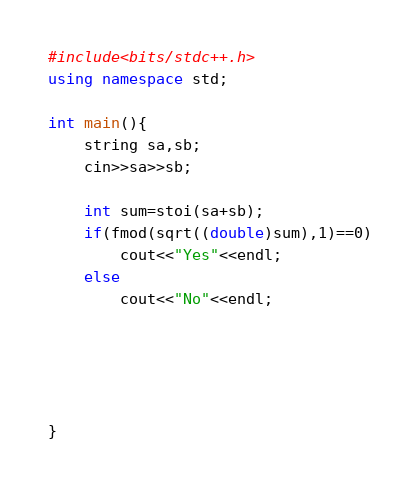Convert code to text. <code><loc_0><loc_0><loc_500><loc_500><_C++_>#include<bits/stdc++.h>
using namespace std;

int main(){
	string sa,sb;
	cin>>sa>>sb;

	int sum=stoi(sa+sb);
	if(fmod(sqrt((double)sum),1)==0)
		cout<<"Yes"<<endl;
	else
		cout<<"No"<<endl;





}
</code> 